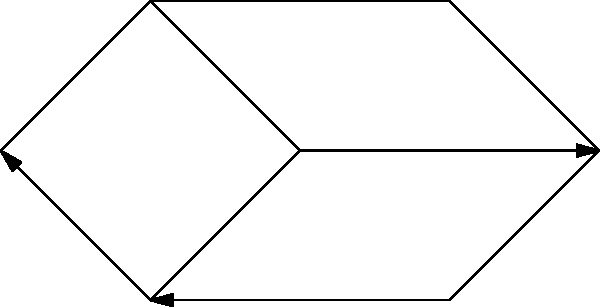In a military communication network, seven units are connected as shown in the diagram. Each edge represents a secure communication channel. What is the minimum number of edges that need to be removed to completely isolate unit 5 from the rest of the network? To solve this problem, we need to analyze the graph and identify all paths that connect unit 5 to other units. Then, we'll determine the minimum number of edges that need to be removed to disconnect all these paths.

Step 1: Identify all paths connecting unit 5 to other units
- Path 1: 5 -- 6 -- 7 -- 4
- Path 2: 5 -- 6 -- 3
- Path 3: 5 -- 2

Step 2: Analyze the edges that need to be removed
- To disconnect Path 1, we need to remove either edge 5-6 or edge 6-7
- To disconnect Path 2, we need to remove either edge 5-6 or edge 6-3
- To disconnect Path 3, we need to remove edge 5-2

Step 3: Determine the minimum number of edges to remove
- If we remove edge 5-6, it disconnects both Path 1 and Path 2
- We still need to remove edge 5-2 to disconnect Path 3

Therefore, the minimum number of edges that need to be removed to completely isolate unit 5 is 2: edge 5-6 and edge 5-2.
Answer: 2 edges 